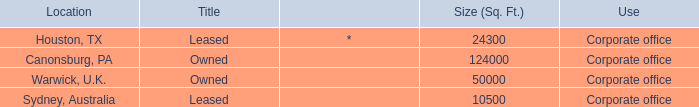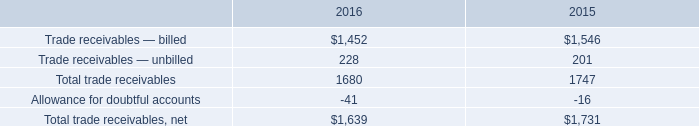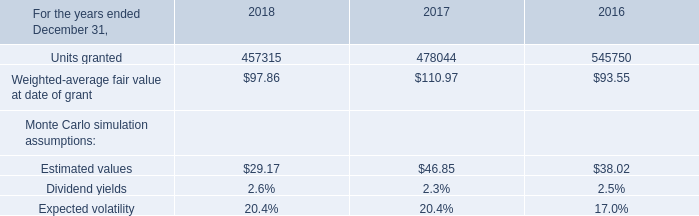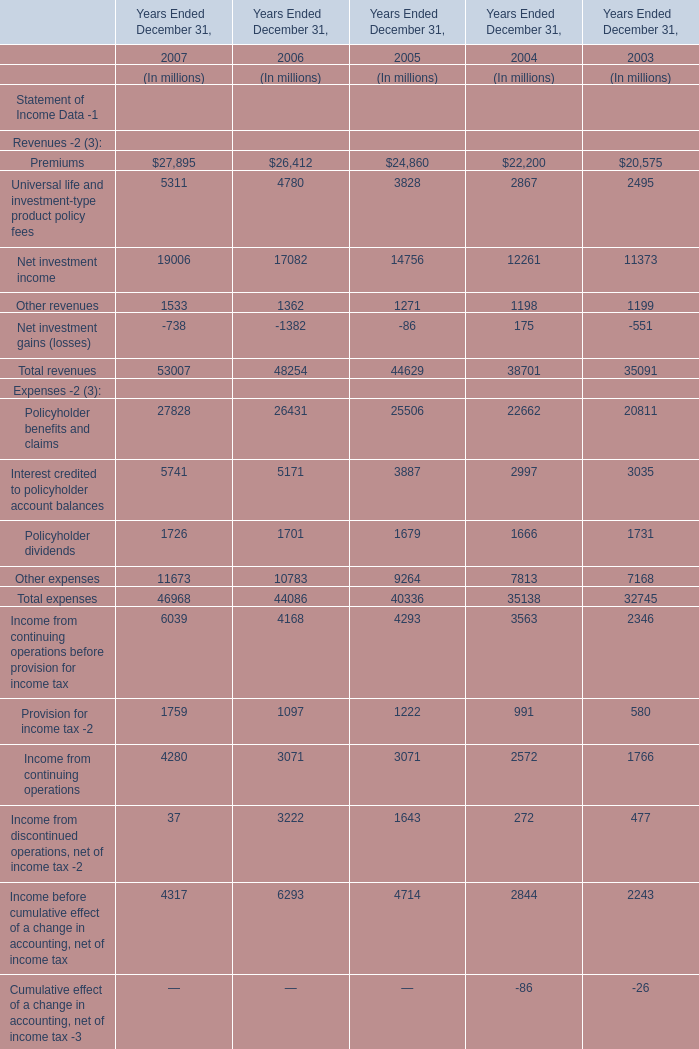In what Year(Ended December 31) is Net income available to common shareholders the highest? 
Answer: 2006. 